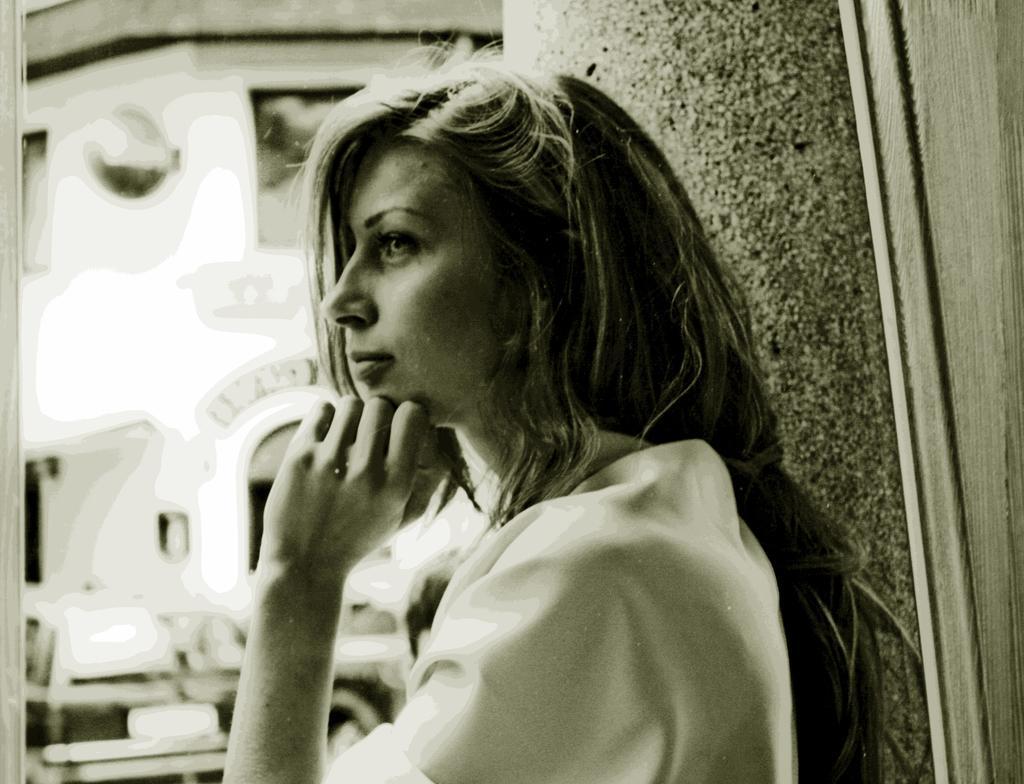How would you summarize this image in a sentence or two? In this picture I can see a woman. 